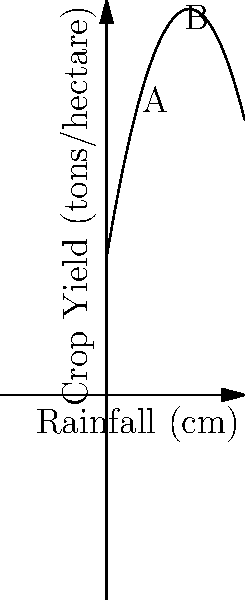As part of a rural development project, you're analyzing the relationship between rainfall and crop yield in Bareri village. The polynomial graph shows the predicted crop yield (in tons per hectare) based on rainfall (in cm). If the rainfall increases from 2 cm (point A) to 8 cm (point B), what is the expected change in crop yield? To solve this problem, we need to follow these steps:

1. Identify the function: The crop yield (y) is a function of rainfall (x), represented by a quadratic equation:
   $y = -0.5x^2 + 6x + 10$

2. Calculate the yield at point A (2 cm rainfall):
   $y_A = -0.5(2)^2 + 6(2) + 10 = -2 + 12 + 10 = 20$ tons/hectare

3. Calculate the yield at point B (8 cm rainfall):
   $y_B = -0.5(8)^2 + 6(8) + 10 = -32 + 48 + 10 = 26$ tons/hectare

4. Calculate the change in yield:
   Change = $y_B - y_A = 26 - 20 = 6$ tons/hectare

Therefore, when the rainfall increases from 2 cm to 8 cm, the expected change in crop yield is an increase of 6 tons per hectare.
Answer: 6 tons/hectare 